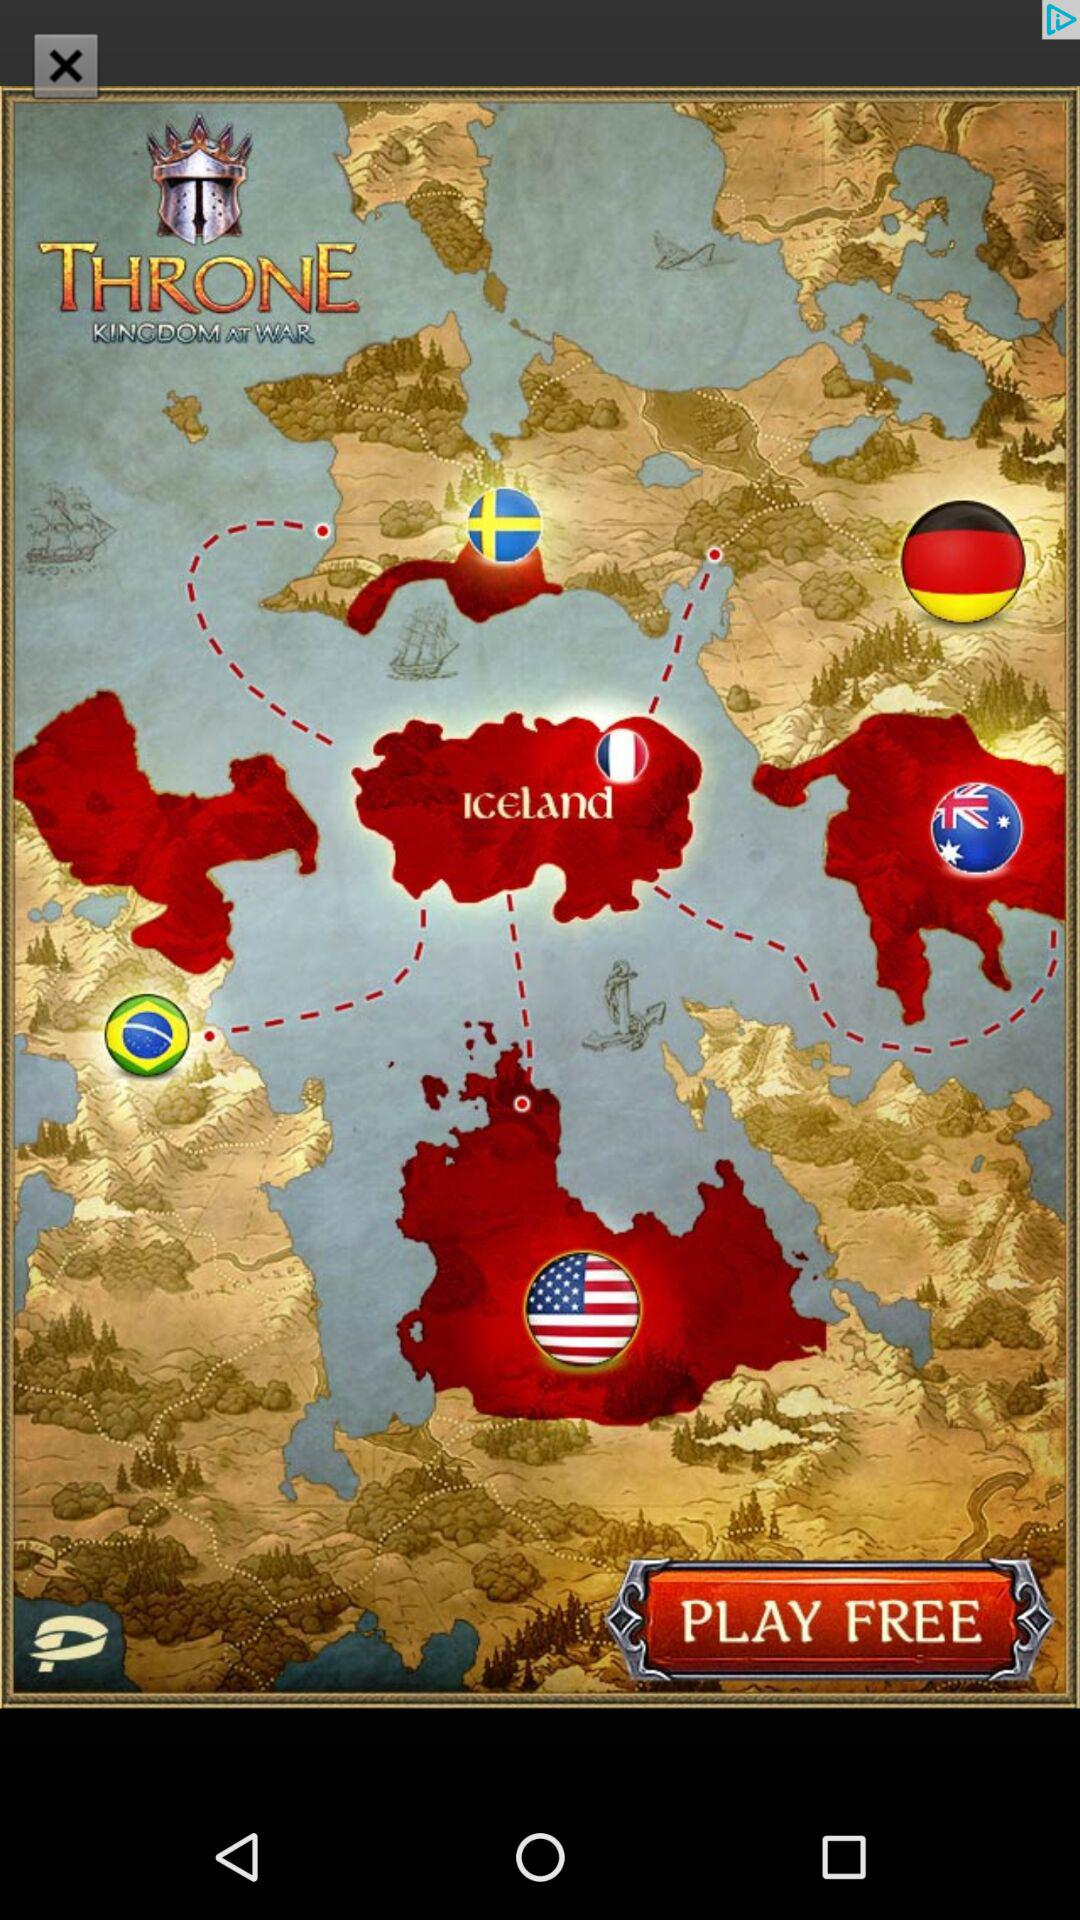What is the version of this application?
When the provided information is insufficient, respond with <no answer>. <no answer> 